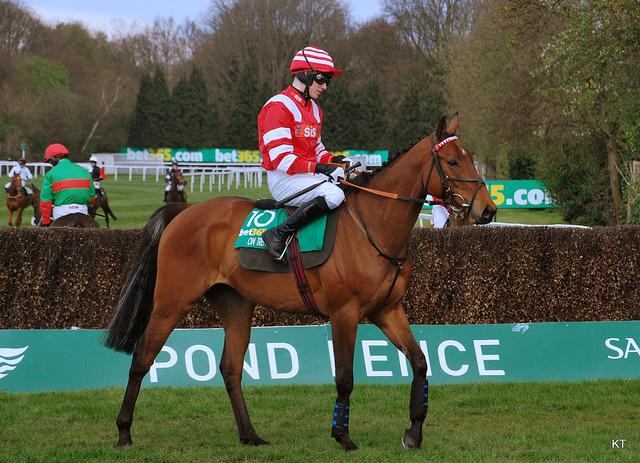What does the man have on his head?
Keep it brief. Helmet. What is the color of the horse?
Quick response, please. Brown. Can this man fall down?
Be succinct. Yes. 